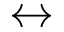<formula> <loc_0><loc_0><loc_500><loc_500>\leftrightarrow</formula> 